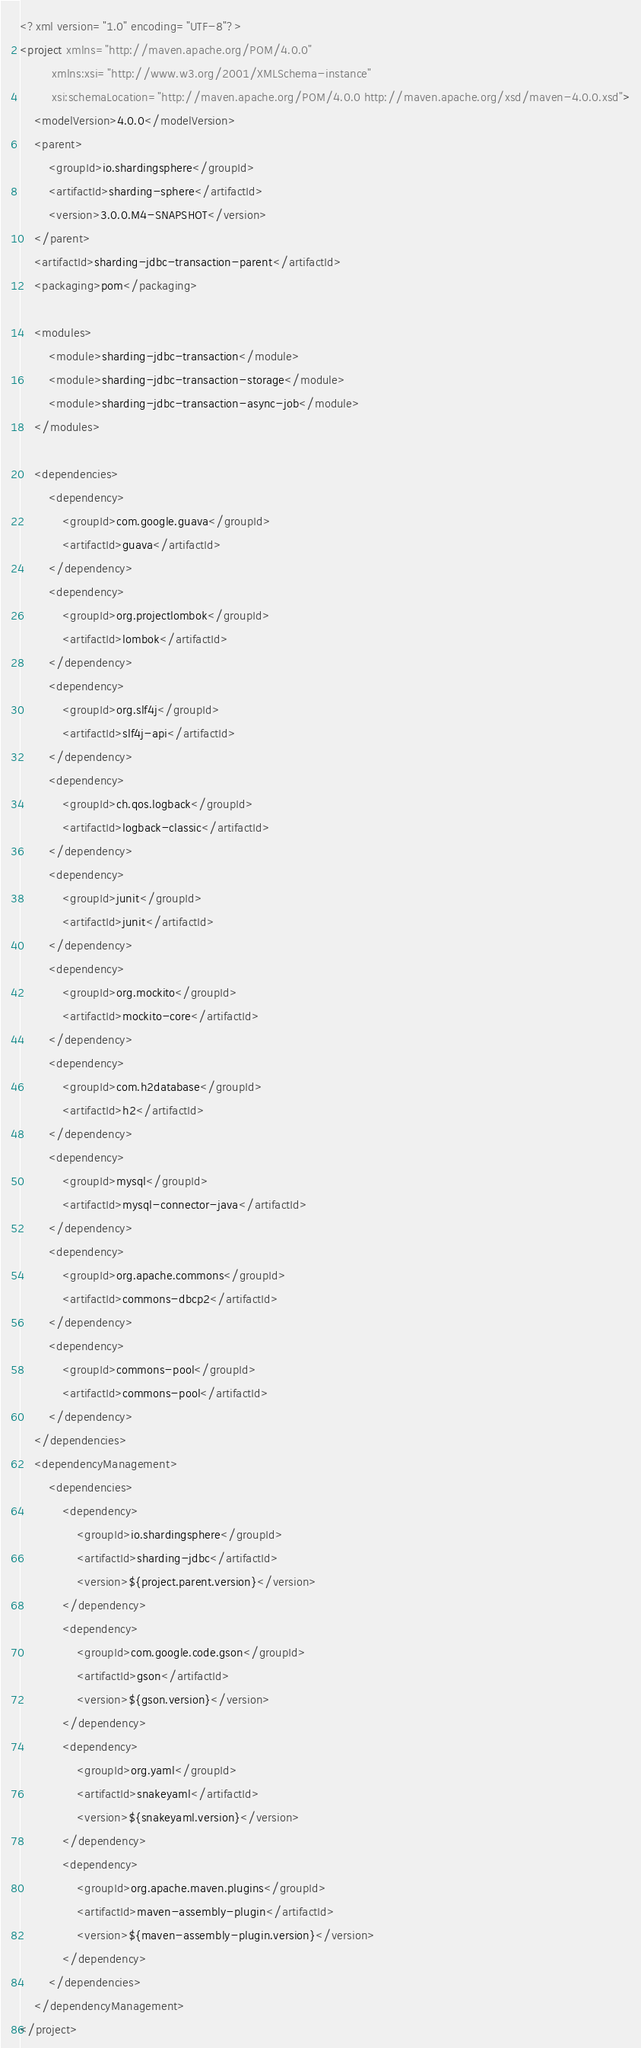<code> <loc_0><loc_0><loc_500><loc_500><_XML_><?xml version="1.0" encoding="UTF-8"?>
<project xmlns="http://maven.apache.org/POM/4.0.0"
         xmlns:xsi="http://www.w3.org/2001/XMLSchema-instance"
         xsi:schemaLocation="http://maven.apache.org/POM/4.0.0 http://maven.apache.org/xsd/maven-4.0.0.xsd">
    <modelVersion>4.0.0</modelVersion>
    <parent>
        <groupId>io.shardingsphere</groupId>
        <artifactId>sharding-sphere</artifactId>
        <version>3.0.0.M4-SNAPSHOT</version>
    </parent>
    <artifactId>sharding-jdbc-transaction-parent</artifactId>
    <packaging>pom</packaging>
    
    <modules>
        <module>sharding-jdbc-transaction</module>
        <module>sharding-jdbc-transaction-storage</module>
        <module>sharding-jdbc-transaction-async-job</module>
    </modules>
    
    <dependencies>
        <dependency>
            <groupId>com.google.guava</groupId>
            <artifactId>guava</artifactId>
        </dependency>
        <dependency>
            <groupId>org.projectlombok</groupId>
            <artifactId>lombok</artifactId>
        </dependency>
        <dependency>
            <groupId>org.slf4j</groupId>
            <artifactId>slf4j-api</artifactId>
        </dependency>
        <dependency>
            <groupId>ch.qos.logback</groupId>
            <artifactId>logback-classic</artifactId>
        </dependency>
        <dependency>
            <groupId>junit</groupId>
            <artifactId>junit</artifactId>
        </dependency>
        <dependency>
            <groupId>org.mockito</groupId>
            <artifactId>mockito-core</artifactId>
        </dependency>
        <dependency>
            <groupId>com.h2database</groupId>
            <artifactId>h2</artifactId>
        </dependency>
        <dependency>
            <groupId>mysql</groupId>
            <artifactId>mysql-connector-java</artifactId>
        </dependency>
        <dependency>
            <groupId>org.apache.commons</groupId>
            <artifactId>commons-dbcp2</artifactId>
        </dependency>
        <dependency>
            <groupId>commons-pool</groupId>
            <artifactId>commons-pool</artifactId>
        </dependency>
    </dependencies>
    <dependencyManagement>
        <dependencies>
            <dependency>
                <groupId>io.shardingsphere</groupId>
                <artifactId>sharding-jdbc</artifactId>
                <version>${project.parent.version}</version>
            </dependency>
            <dependency>
                <groupId>com.google.code.gson</groupId>
                <artifactId>gson</artifactId>
                <version>${gson.version}</version>
            </dependency>
            <dependency>
                <groupId>org.yaml</groupId>
                <artifactId>snakeyaml</artifactId>
                <version>${snakeyaml.version}</version>
            </dependency>
            <dependency>
                <groupId>org.apache.maven.plugins</groupId>
                <artifactId>maven-assembly-plugin</artifactId>
                <version>${maven-assembly-plugin.version}</version>
            </dependency>
        </dependencies>
    </dependencyManagement>
</project>
</code> 